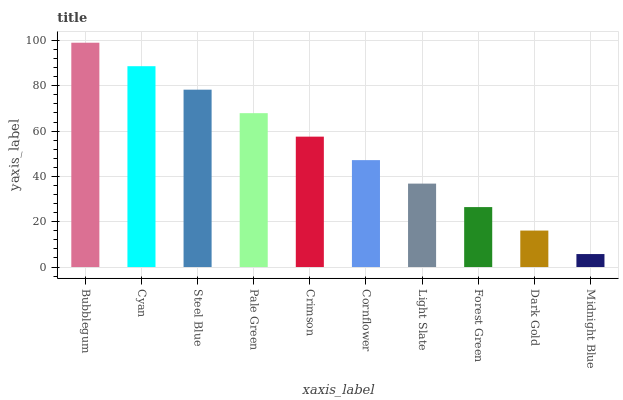Is Midnight Blue the minimum?
Answer yes or no. Yes. Is Bubblegum the maximum?
Answer yes or no. Yes. Is Cyan the minimum?
Answer yes or no. No. Is Cyan the maximum?
Answer yes or no. No. Is Bubblegum greater than Cyan?
Answer yes or no. Yes. Is Cyan less than Bubblegum?
Answer yes or no. Yes. Is Cyan greater than Bubblegum?
Answer yes or no. No. Is Bubblegum less than Cyan?
Answer yes or no. No. Is Crimson the high median?
Answer yes or no. Yes. Is Cornflower the low median?
Answer yes or no. Yes. Is Forest Green the high median?
Answer yes or no. No. Is Forest Green the low median?
Answer yes or no. No. 